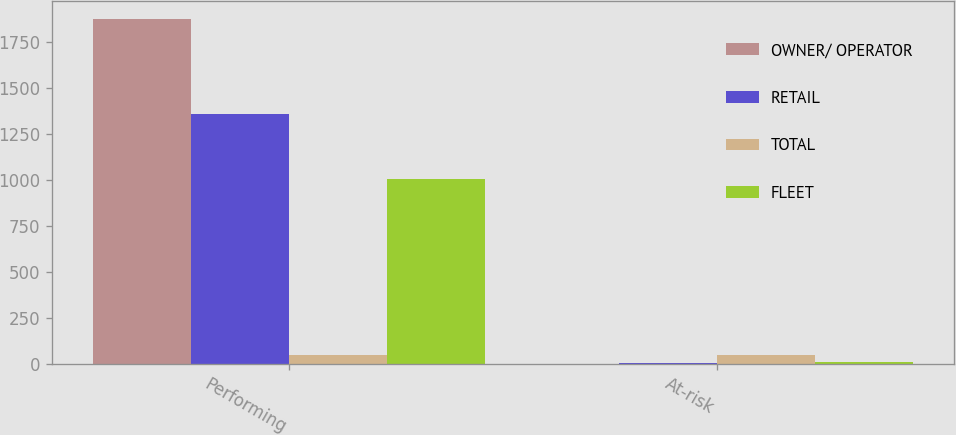<chart> <loc_0><loc_0><loc_500><loc_500><stacked_bar_chart><ecel><fcel>Performing<fcel>At-risk<nl><fcel>OWNER/ OPERATOR<fcel>1874.5<fcel>0.1<nl><fcel>RETAIL<fcel>1354.7<fcel>4<nl><fcel>TOTAL<fcel>44.7<fcel>44.7<nl><fcel>FLEET<fcel>1005.2<fcel>6.1<nl></chart> 